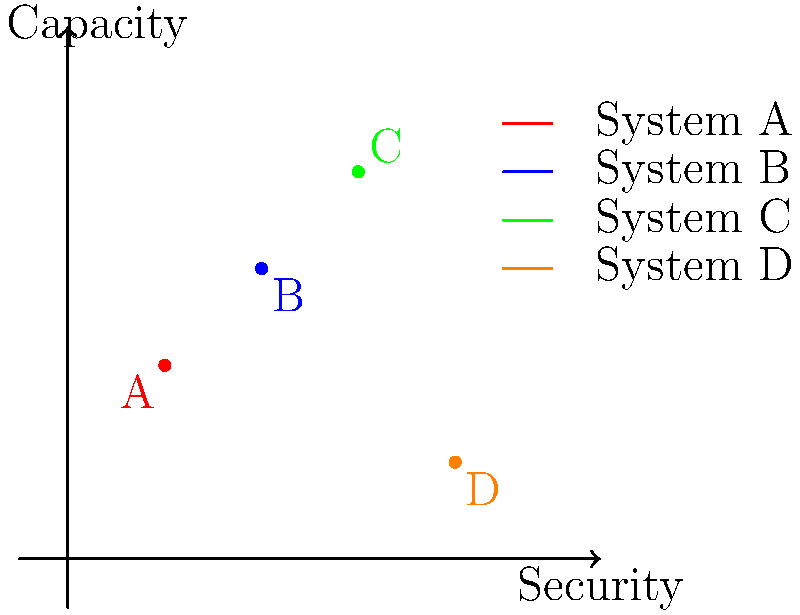As a medical professional concerned with patient confidentiality, you are evaluating four secure file storage systems (A, B, C, and D) based on their security level and storage capacity. The graph shows the relative positions of these systems. Which system offers the best balance of high security and high capacity for storing sensitive patient data? To determine the best system, we need to analyze the graph and compare the security and capacity levels of each system:

1. System A (1,2): Low security, low-to-medium capacity
2. System B (2,3): Medium security, medium capacity
3. System C (3,4): High security, high capacity
4. System D (4,1): Very high security, very low capacity

Step 1: Eliminate systems with clear disadvantages
- System A can be eliminated due to its low security, which is crucial for patient data.
- System D can be eliminated due to its very low capacity, despite high security.

Step 2: Compare the remaining systems
- System B offers a balanced approach but is outperformed by System C in both aspects.
- System C provides both high security and high capacity.

Step 3: Consider the medical context
In a medical setting, both high security (to protect patient confidentiality) and high capacity (to store large amounts of patient data) are crucial.

Step 4: Make the final decision
System C offers the best balance of high security and high capacity, making it the most suitable choice for storing sensitive patient data in a medical setting.
Answer: System C 